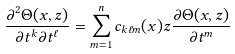Convert formula to latex. <formula><loc_0><loc_0><loc_500><loc_500>\frac { \partial ^ { 2 } \Theta ( x , z ) } { \partial t ^ { k } \partial t ^ { \ell } } = \sum _ { m = 1 } ^ { n } c _ { k \ell m } ( x ) z \frac { \partial \Theta ( x , z ) } { \partial t ^ { m } }</formula> 